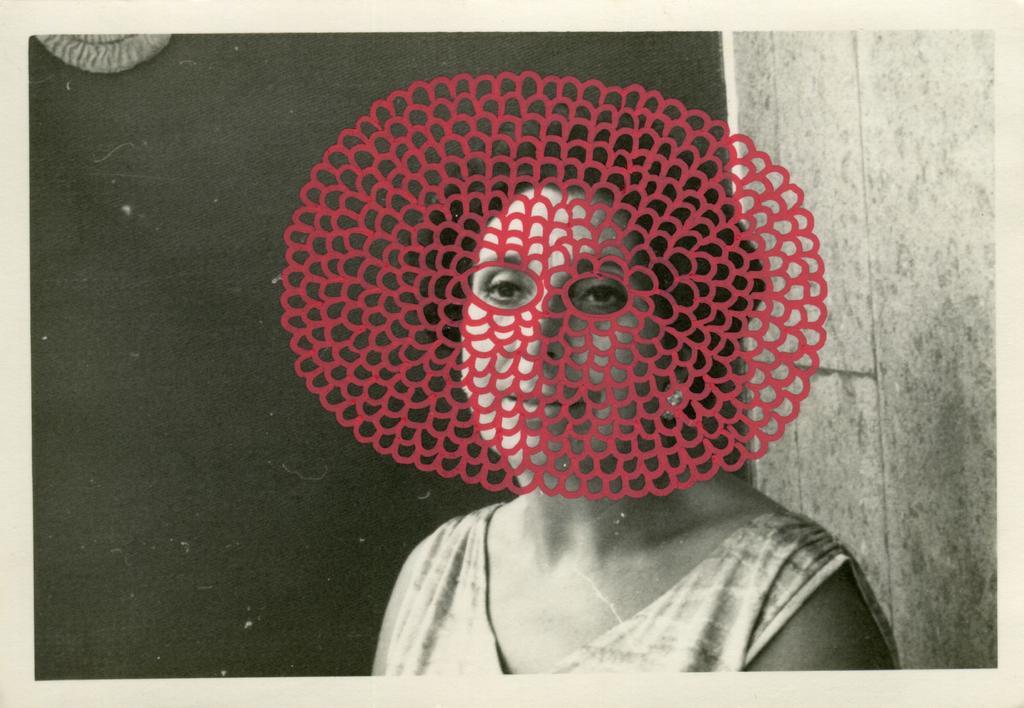Could you give a brief overview of what you see in this image? In this image there is one women is at right side of this image and there is one design which is in red color is in middle of this image and there is a wall in the background. there is one object kept at top left corner of this image. 